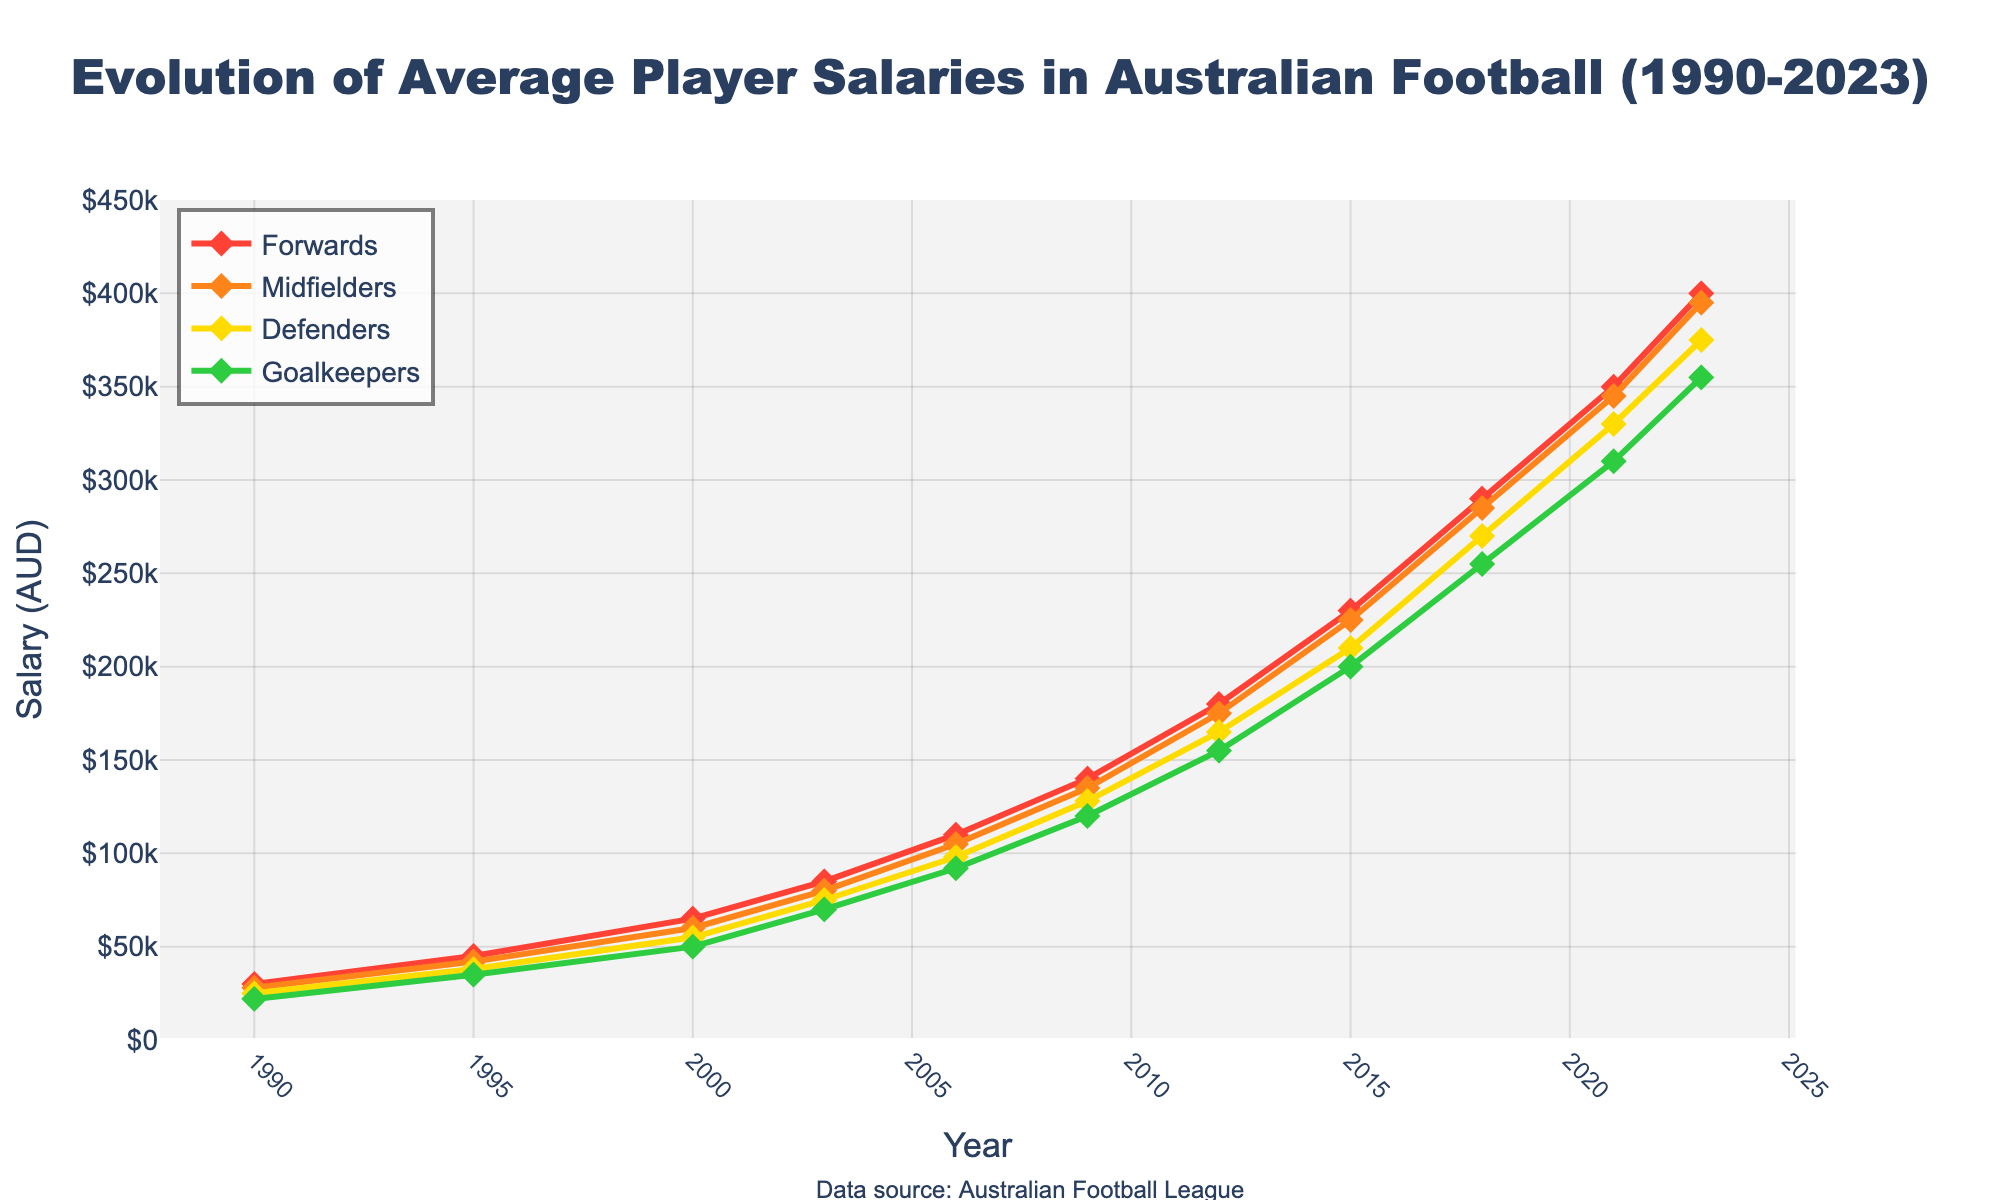What's the average salary for Goalkeepers in 2023? The chart shows that the salary for Goalkeepers in 2023 is $355,000.
Answer: \$355,000 Which position had the highest salary growth from 1990 to 2023? Forwards had the highest salary growth, starting from $30,000 in 1990 and reaching $400,000 in 2023, which is an increase of $370,000.
Answer: Forwards What is the difference in salaries between Midfielders and Defenders in 2023? In 2023, the salary for Midfielders is $395,000, and for Defenders, it is $375,000. The difference is $395,000 - $375,000 = $20,000.
Answer: \$20,000 Compare the salaries of Goalkeepers and Forwards in 2009. In 2009, the salary for Goalkeepers is $120,000, and for Forwards, it is $140,000. Forwards earn more.
Answer: Forwards What was the average salary of all positions in 2015? In 2015, the salaries are: Forwards: $230,000, Midfielders: $225,000, Defenders: $210,000, and Goalkeepers: $200,000. The average is (230,000 + 225,000 + 210,000 + 200,000)/4 = $216,250.
Answer: \$216,250 Which position showed an equal salary increase in both 2000 to 2003 and 2006 to 2009? Midfielders' salaries increased by $20,000 in both periods: from $60,000 to $80,000 (2000 to 2003) and from $105,000 to $135,000 (2006 to 2009).
Answer: Midfielders What visual attribute differentiates the lines for each position? Each line representing a position is differentiated by color: Forwards (red), Midfielders (orange), Defenders (yellow), Goalkeepers (green).
Answer: Color How much did the salary for Defenders increase from 1990 to 2023? The salary for Defenders increased from $25,000 in 1990 to $375,000 in 2023. The increase is $375,000 - $25,000 = $350,000.
Answer: \$350,000 Which year shows the highest salary for Midfielders? The highest salary for Midfielders is in 2023, where it reaches $395,000.
Answer: 2023 Between 2003 and 2006, which position had the largest salary increase? Forwards had the largest salary increase, from $85,000 in 2003 to $110,000 in 2006, which is an increase of $25,000.
Answer: Forwards 